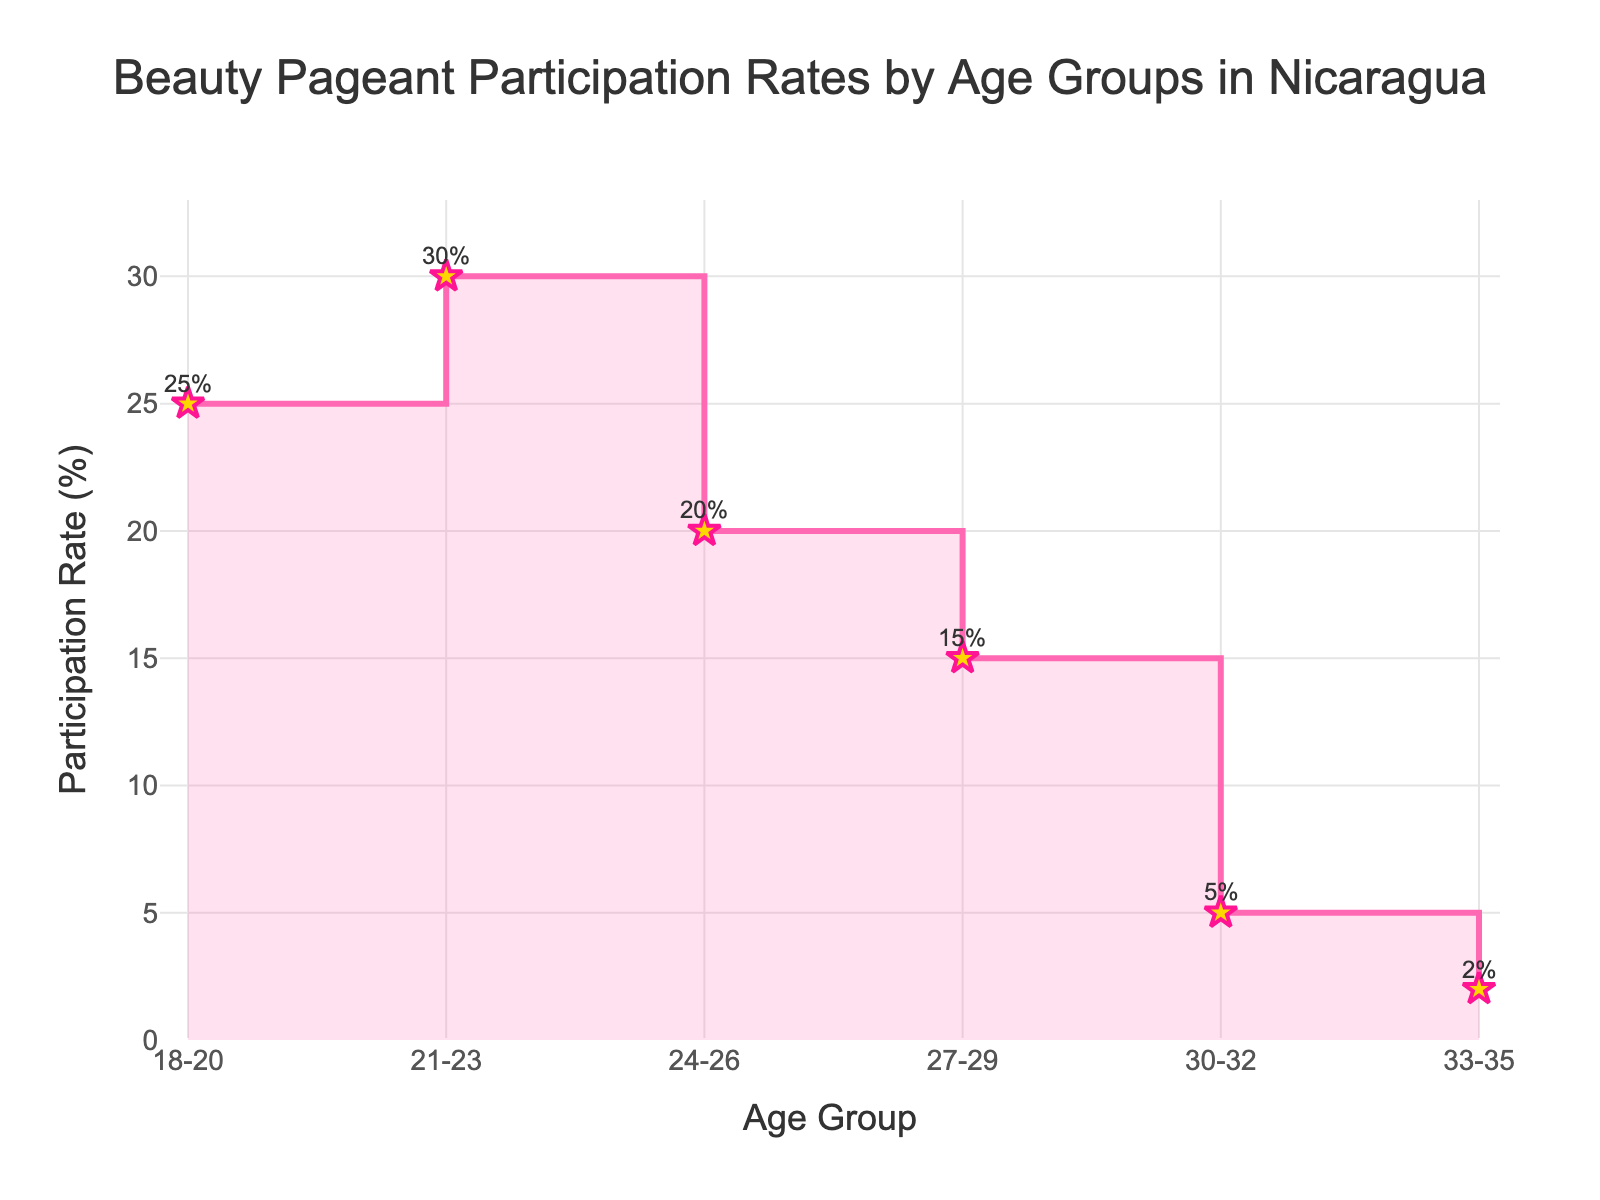What is the participation rate for the age group 21-23? The figure indicates that the participation rate for the age group 21-23 is 30%.
Answer: 30% How many age groups are represented in the figure? The figure shows the "Age Group" on the x-axis. Counting the distinct labels, there are six age groups displayed.
Answer: 6 Which age group has the highest participation rate? The highest point on the y-axis in the figure corresponds to the age group 21-23, with a participation rate of 30%.
Answer: 21-23 What is the participation rate difference between the youngest age group (18-20) and the oldest age group (33-35)? The participation rate for the age group 18-20 is 25%, and for the age group 33-35, it is 2%. The difference is 25% - 2% = 23%.
Answer: 23% By how much does the participation rate decrease from the age group 24-26 to 27-29? The participation rate for the age group 24-26 is 20%, and for the age group 27-29, it is 15%. The amount it decreases is 20% - 15% = 5%.
Answer: 5% Compare the participation rates of the age group 21-23 and 30-32. Which one is higher and by how much? The age group 21-23 has a participation rate of 30%, and the age group 30-32 has a participation rate of 5%. The difference is 30% - 5% = 25%, so the age group 21-23 is higher by 25%.
Answer: 21-23 by 25% What's the average participation rate of all the age groups? Sum of all participation rates (25% + 30% + 20% + 15% + 5% + 2%) = 97%. Number of age groups = 6. The average is 97% / 6 ≈ 16.17%.
Answer: 16.17% Which age group shows the biggest decline in participation rates compared to its preceding age group? By reviewing the differences: from 18-20 to 21-23 is +5%, 21-23 to 24-26 is -10%, 24-26 to 27-29 is -5%, 27-29 to 30-32 is -10%, and 30-32 to 33-35 is -3%. The largest decline, -10%, occurs from 21-23 to 24-26 and from 27-29 to 30-32.
Answer: 21-23 to 24-26 and 27-29 to 30-32 How does the participation rate trend change between the age groups 18-20 to 30-32? The trend starts at 25% (18-20), increases to 30% (21-23), then decreases sequentially to 20% (24-26), 15% (27-29), and 5% (30-32). The general trend demonstrates an initial increase followed by a consistent decline.
Answer: Initial increase, then decline What's the median participation rate of all the age groups? Ordering the participation rates: 2%, 5%, 15%, 20%, 25%, 30%. The median is the average of the middle two values (15% + 20%) / 2 = 17.5%.
Answer: 17.5% 